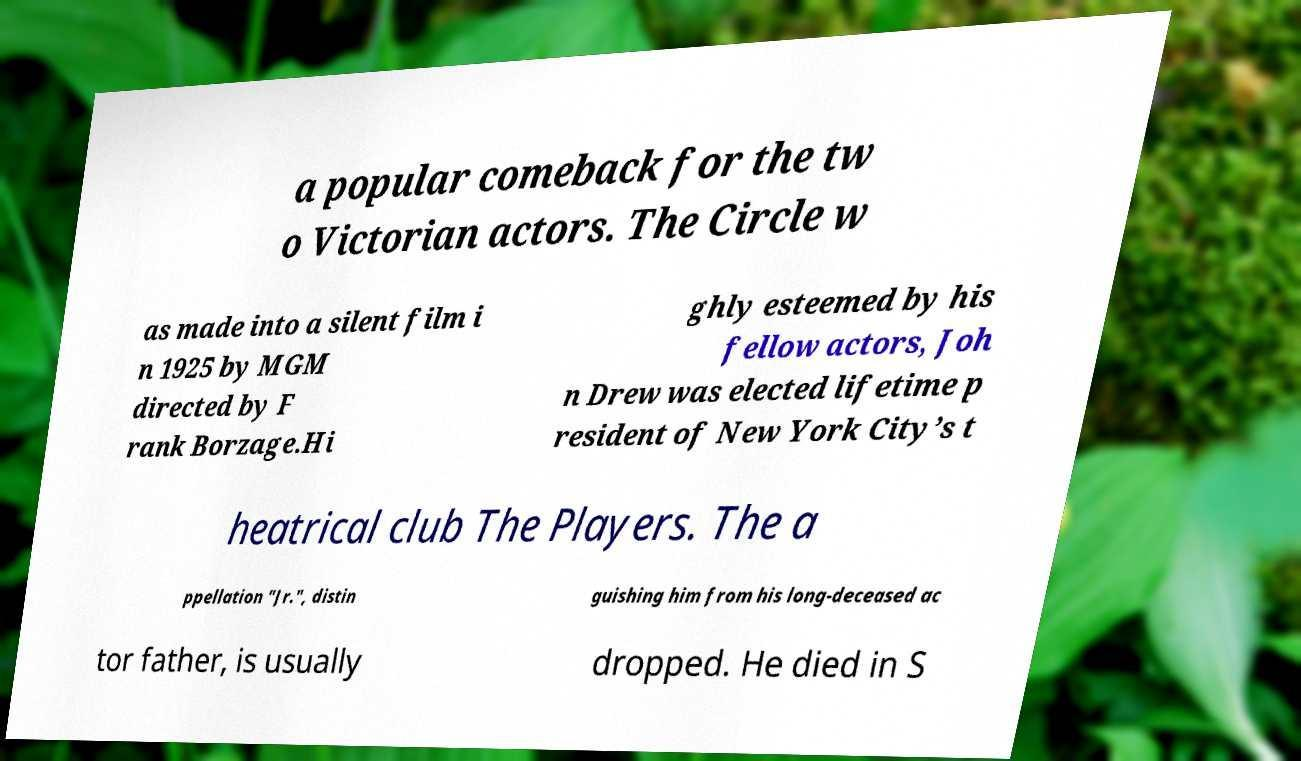Can you read and provide the text displayed in the image?This photo seems to have some interesting text. Can you extract and type it out for me? a popular comeback for the tw o Victorian actors. The Circle w as made into a silent film i n 1925 by MGM directed by F rank Borzage.Hi ghly esteemed by his fellow actors, Joh n Drew was elected lifetime p resident of New York City’s t heatrical club The Players. The a ppellation "Jr.", distin guishing him from his long-deceased ac tor father, is usually dropped. He died in S 